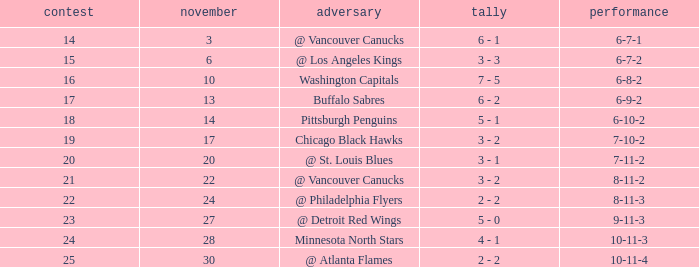What is the game when on november 27? 23.0. 